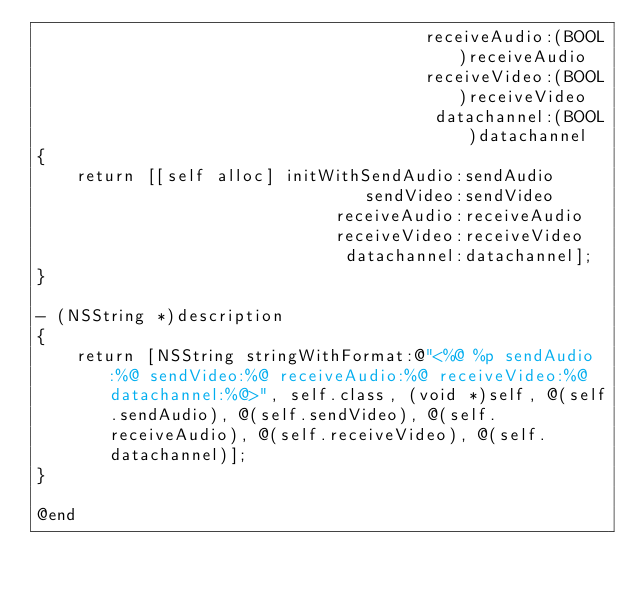Convert code to text. <code><loc_0><loc_0><loc_500><loc_500><_ObjectiveC_>                                       receiveAudio:(BOOL)receiveAudio
                                       receiveVideo:(BOOL)receiveVideo
                                        datachannel:(BOOL)datachannel
{
    return [[self alloc] initWithSendAudio:sendAudio
                                 sendVideo:sendVideo
                              receiveAudio:receiveAudio
                              receiveVideo:receiveVideo
                               datachannel:datachannel];
}

- (NSString *)description
{
    return [NSString stringWithFormat:@"<%@ %p sendAudio:%@ sendVideo:%@ receiveAudio:%@ receiveVideo:%@ datachannel:%@>", self.class, (void *)self, @(self.sendAudio), @(self.sendVideo), @(self.receiveAudio), @(self.receiveVideo), @(self.datachannel)];
}

@end
</code> 